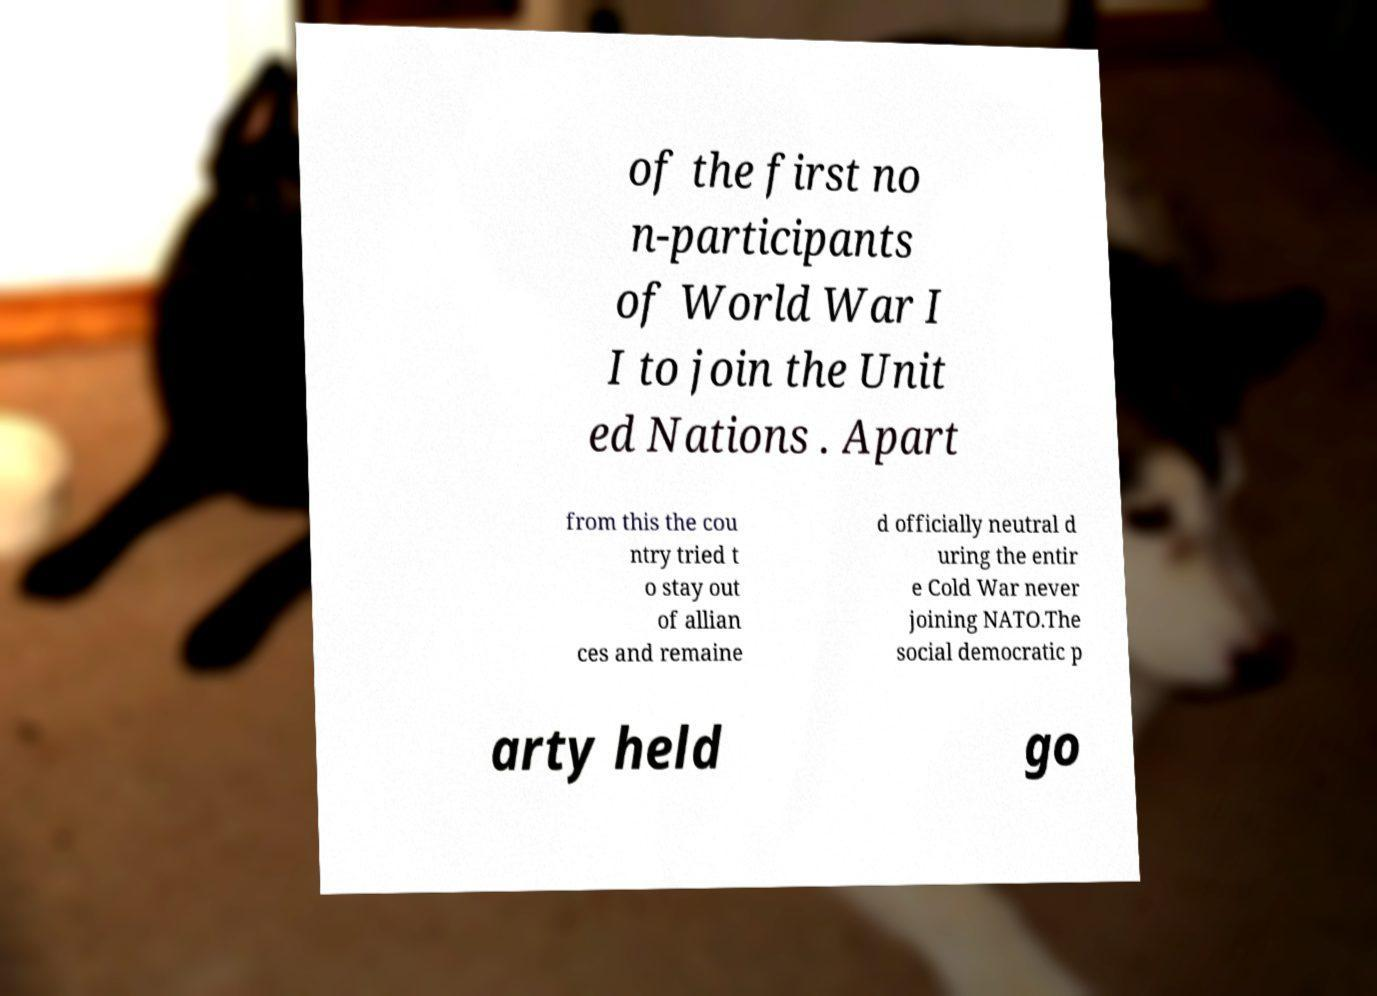Can you accurately transcribe the text from the provided image for me? of the first no n-participants of World War I I to join the Unit ed Nations . Apart from this the cou ntry tried t o stay out of allian ces and remaine d officially neutral d uring the entir e Cold War never joining NATO.The social democratic p arty held go 